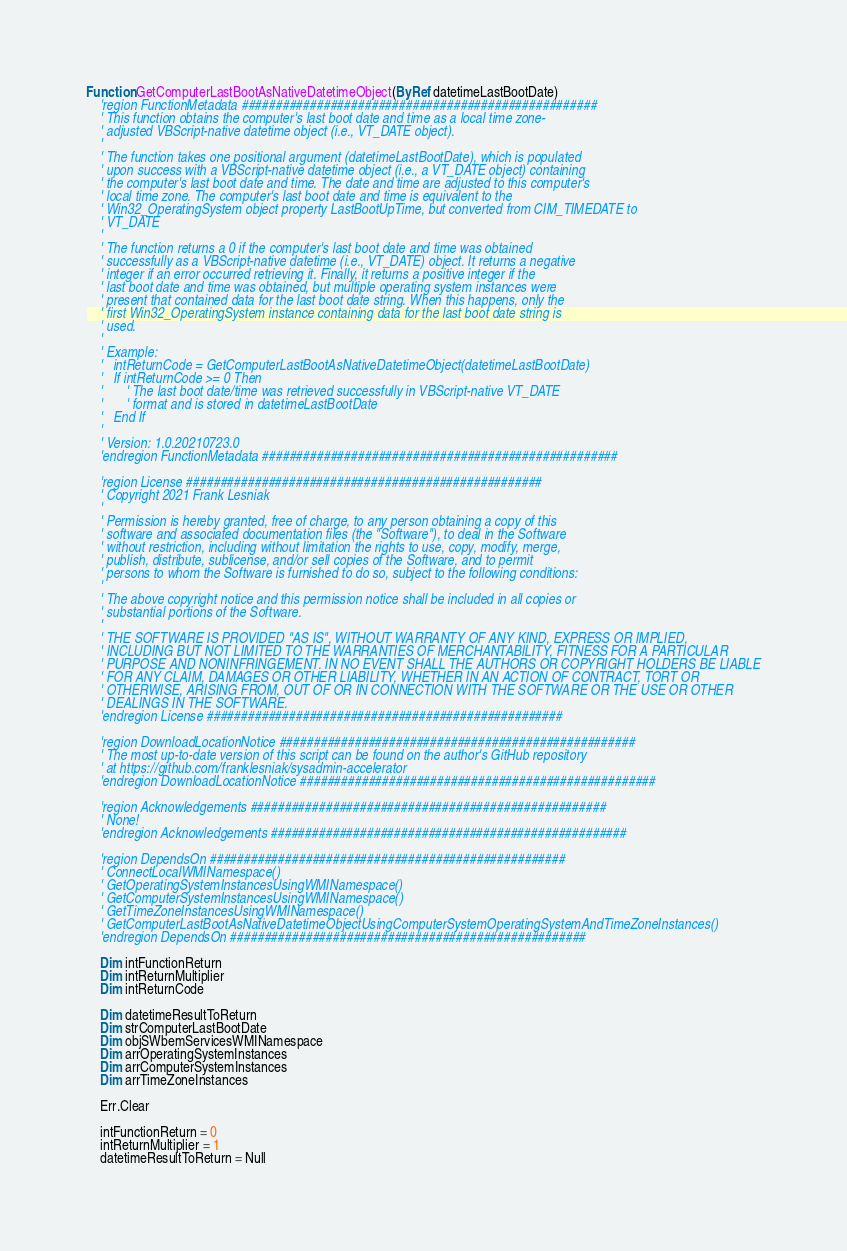Convert code to text. <code><loc_0><loc_0><loc_500><loc_500><_VisualBasic_>Function GetComputerLastBootAsNativeDatetimeObject(ByRef datetimeLastBootDate)
    'region FunctionMetadata ####################################################
    ' This function obtains the computer's last boot date and time as a local time zone-
    ' adjusted VBScript-native datetime object (i.e., VT_DATE object).
    '
    ' The function takes one positional argument (datetimeLastBootDate), which is populated
    ' upon success with a VBScript-native datetime object (i.e., a VT_DATE object) containing
    ' the computer's last boot date and time. The date and time are adjusted to this computer's
    ' local time zone. The computer's last boot date and time is equivalent to the
    ' Win32_OperatingSystem object property LastBootUpTime, but converted from CIM_TIMEDATE to
    ' VT_DATE
    '
    ' The function returns a 0 if the computer's last boot date and time was obtained
    ' successfully as a VBScript-native datetime (i.e., VT_DATE) object. It returns a negative
    ' integer if an error occurred retrieving it. Finally, it returns a positive integer if the
    ' last boot date and time was obtained, but multiple operating system instances were
    ' present that contained data for the last boot date string. When this happens, only the
    ' first Win32_OperatingSystem instance containing data for the last boot date string is
    ' used.
    '
    ' Example:
    '   intReturnCode = GetComputerLastBootAsNativeDatetimeObject(datetimeLastBootDate)
    '   If intReturnCode >= 0 Then
    '       ' The last boot date/time was retrieved successfully in VBScript-native VT_DATE
    '       ' format and is stored in datetimeLastBootDate
    '   End If
    '
    ' Version: 1.0.20210723.0
    'endregion FunctionMetadata ####################################################

    'region License ####################################################
    ' Copyright 2021 Frank Lesniak
    '
    ' Permission is hereby granted, free of charge, to any person obtaining a copy of this
    ' software and associated documentation files (the "Software"), to deal in the Software
    ' without restriction, including without limitation the rights to use, copy, modify, merge,
    ' publish, distribute, sublicense, and/or sell copies of the Software, and to permit
    ' persons to whom the Software is furnished to do so, subject to the following conditions:
    '
    ' The above copyright notice and this permission notice shall be included in all copies or
    ' substantial portions of the Software.
    '
    ' THE SOFTWARE IS PROVIDED "AS IS", WITHOUT WARRANTY OF ANY KIND, EXPRESS OR IMPLIED,
    ' INCLUDING BUT NOT LIMITED TO THE WARRANTIES OF MERCHANTABILITY, FITNESS FOR A PARTICULAR
    ' PURPOSE AND NONINFRINGEMENT. IN NO EVENT SHALL THE AUTHORS OR COPYRIGHT HOLDERS BE LIABLE
    ' FOR ANY CLAIM, DAMAGES OR OTHER LIABILITY, WHETHER IN AN ACTION OF CONTRACT, TORT OR
    ' OTHERWISE, ARISING FROM, OUT OF OR IN CONNECTION WITH THE SOFTWARE OR THE USE OR OTHER
    ' DEALINGS IN THE SOFTWARE.
    'endregion License ####################################################

    'region DownloadLocationNotice ####################################################
    ' The most up-to-date version of this script can be found on the author's GitHub repository
    ' at https://github.com/franklesniak/sysadmin-accelerator
    'endregion DownloadLocationNotice ####################################################

    'region Acknowledgements ####################################################
    ' None!
    'endregion Acknowledgements ####################################################

    'region DependsOn ####################################################
    ' ConnectLocalWMINamespace()
    ' GetOperatingSystemInstancesUsingWMINamespace()
    ' GetComputerSystemInstancesUsingWMINamespace()
    ' GetTimeZoneInstancesUsingWMINamespace()
    ' GetComputerLastBootAsNativeDatetimeObjectUsingComputerSystemOperatingSystemAndTimeZoneInstances()
    'endregion DependsOn ####################################################

    Dim intFunctionReturn
    Dim intReturnMultiplier
    Dim intReturnCode

    Dim datetimeResultToReturn
    Dim strComputerLastBootDate
    Dim objSWbemServicesWMINamespace
    Dim arrOperatingSystemInstances
    Dim arrComputerSystemInstances
    Dim arrTimeZoneInstances

    Err.Clear

    intFunctionReturn = 0
    intReturnMultiplier = 1
    datetimeResultToReturn = Null
</code> 